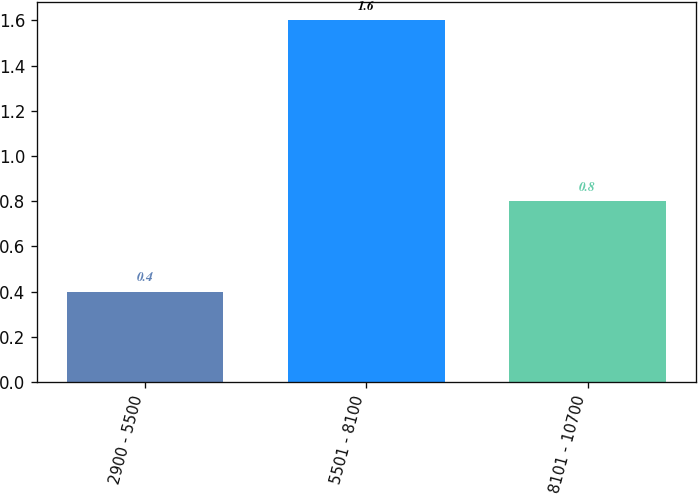Convert chart to OTSL. <chart><loc_0><loc_0><loc_500><loc_500><bar_chart><fcel>2900 - 5500<fcel>5501 - 8100<fcel>8101 - 10700<nl><fcel>0.4<fcel>1.6<fcel>0.8<nl></chart> 